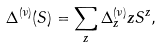Convert formula to latex. <formula><loc_0><loc_0><loc_500><loc_500>\Delta ^ { ( \nu ) } ( S ) = \sum _ { z } \Delta _ { z } ^ { ( \nu ) } z S ^ { z } ,</formula> 